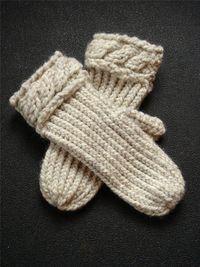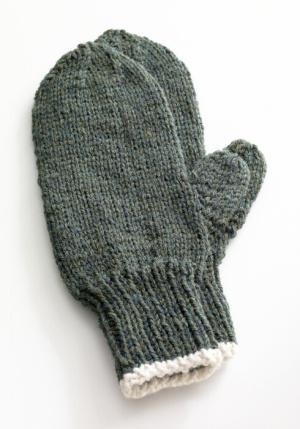The first image is the image on the left, the second image is the image on the right. Examine the images to the left and right. Is the description "Both pairs of mittens are different shades of the same colors." accurate? Answer yes or no. No. The first image is the image on the left, the second image is the image on the right. Considering the images on both sides, is "The left and right image contains the same number of mittens." valid? Answer yes or no. Yes. 